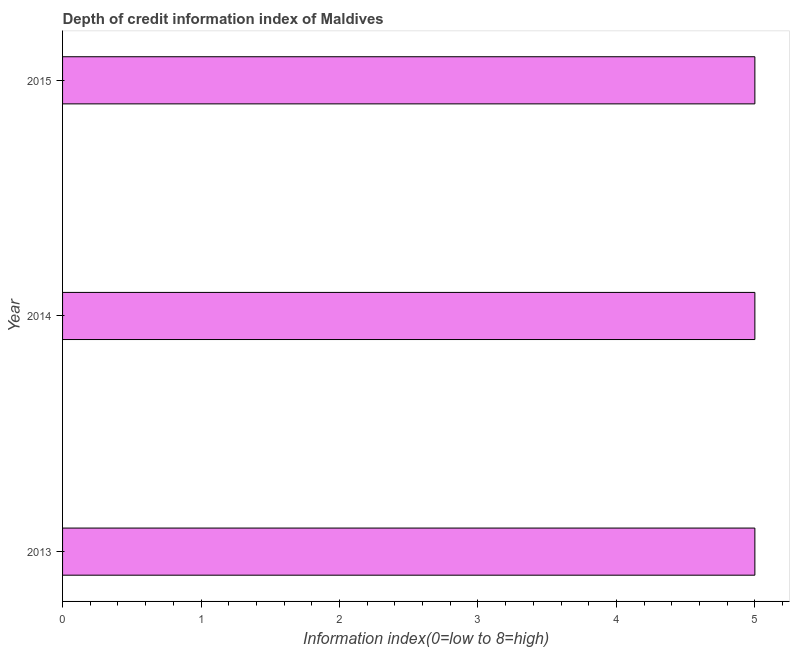Does the graph contain any zero values?
Offer a very short reply. No. What is the title of the graph?
Your answer should be compact. Depth of credit information index of Maldives. What is the label or title of the X-axis?
Your response must be concise. Information index(0=low to 8=high). What is the label or title of the Y-axis?
Your answer should be very brief. Year. What is the depth of credit information index in 2014?
Provide a succinct answer. 5. Across all years, what is the minimum depth of credit information index?
Your answer should be compact. 5. In which year was the depth of credit information index maximum?
Provide a succinct answer. 2013. What is the average depth of credit information index per year?
Make the answer very short. 5. In how many years, is the depth of credit information index greater than 0.6 ?
Keep it short and to the point. 3. Is the difference between the depth of credit information index in 2014 and 2015 greater than the difference between any two years?
Your answer should be compact. Yes. What is the difference between the highest and the second highest depth of credit information index?
Provide a short and direct response. 0. What is the difference between the highest and the lowest depth of credit information index?
Offer a terse response. 0. How many bars are there?
Your answer should be very brief. 3. What is the ratio of the Information index(0=low to 8=high) in 2013 to that in 2014?
Keep it short and to the point. 1. What is the ratio of the Information index(0=low to 8=high) in 2014 to that in 2015?
Give a very brief answer. 1. 